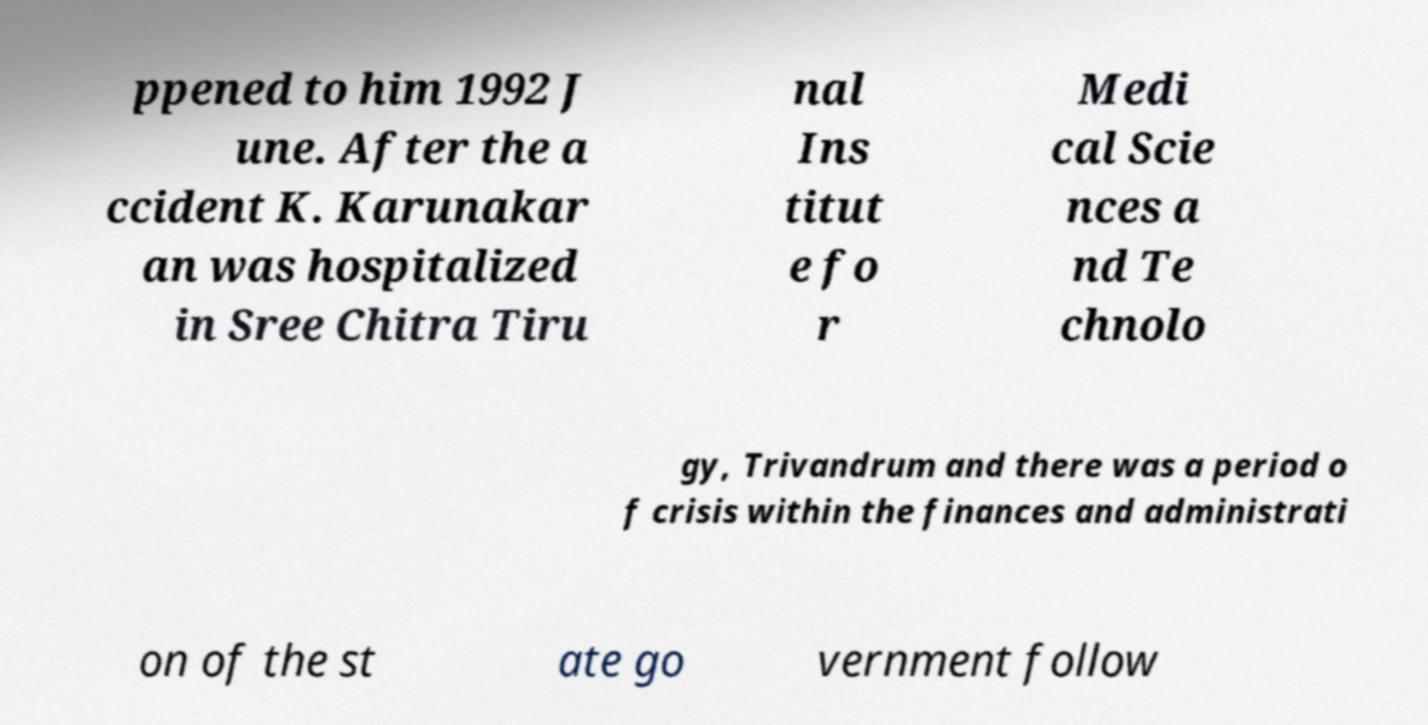For documentation purposes, I need the text within this image transcribed. Could you provide that? ppened to him 1992 J une. After the a ccident K. Karunakar an was hospitalized in Sree Chitra Tiru nal Ins titut e fo r Medi cal Scie nces a nd Te chnolo gy, Trivandrum and there was a period o f crisis within the finances and administrati on of the st ate go vernment follow 